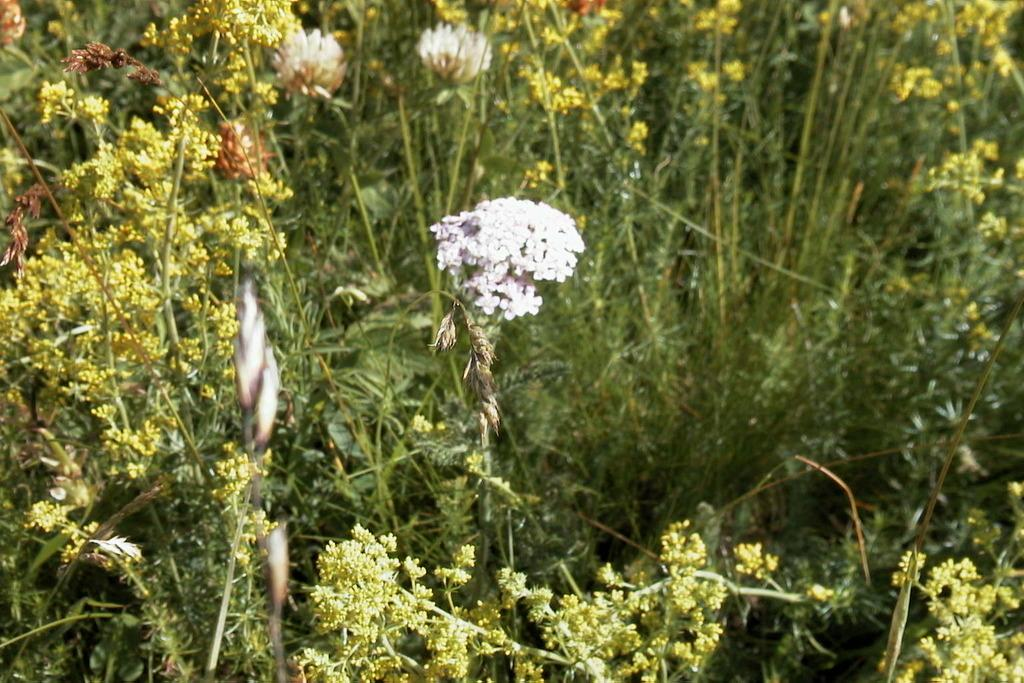What type of photography is used in the image? The image is a macro photography. What is the main subject of the image? There is a flower bunch in the image. How is the background of the image depicted? The background of the image is blurred. Can you hear the flower bunch crying in the image? There is no sound in the image, and flowers do not have the ability to cry. 